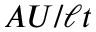<formula> <loc_0><loc_0><loc_500><loc_500>A U / \ell t</formula> 